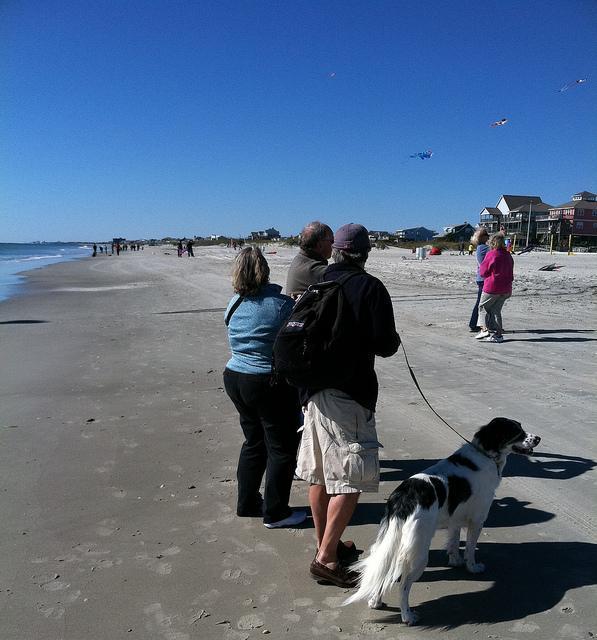How many dogs are in the photo?
Give a very brief answer. 1. How many people can be seen?
Give a very brief answer. 4. 